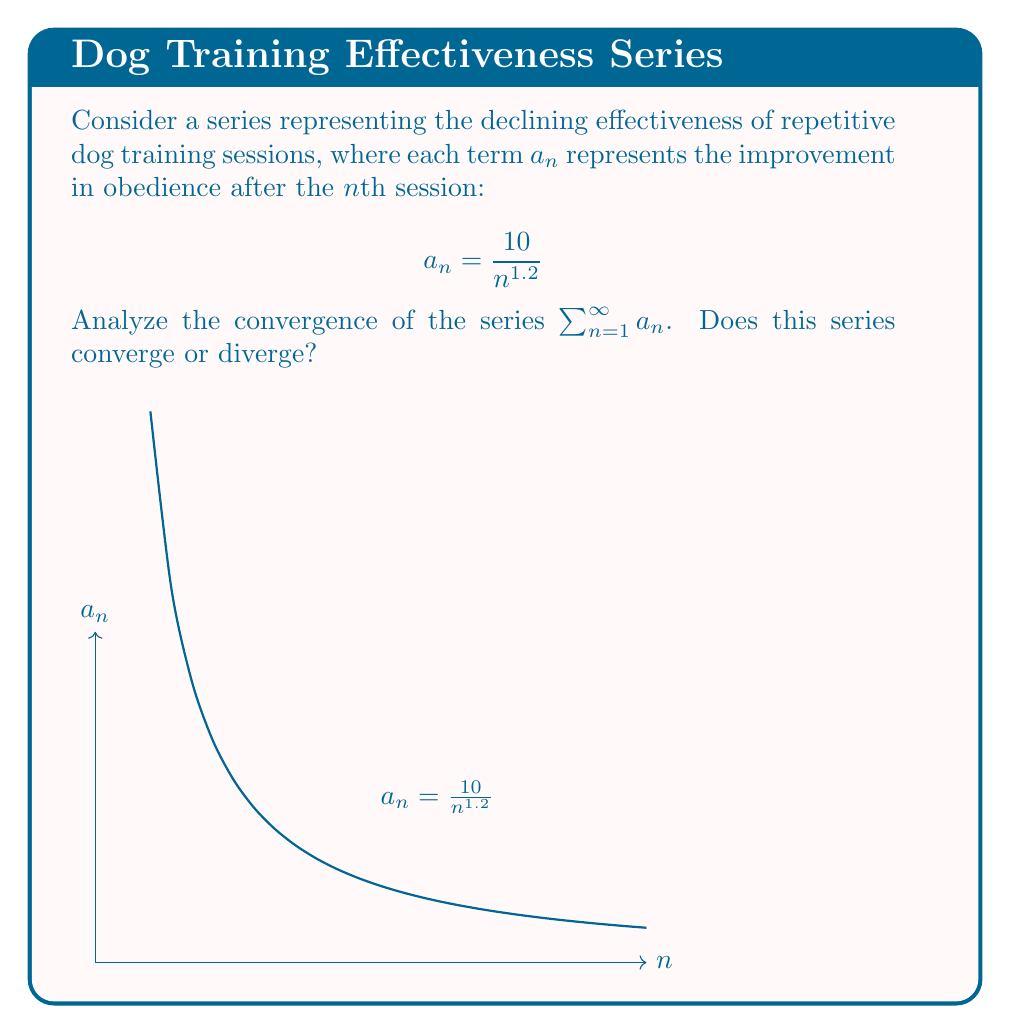What is the answer to this math problem? To analyze the convergence of this series, we can use the p-series test:

1) The general form of a p-series is $\sum_{n=1}^{\infty} \frac{1}{n^p}$

2) Our series can be rewritten as $\sum_{n=1}^{\infty} \frac{10}{n^{1.2}} = 10 \sum_{n=1}^{\infty} \frac{1}{n^{1.2}}$

3) In this case, $p = 1.2$

4) For a p-series:
   - If $p > 1$, the series converges
   - If $p \leq 1$, the series diverges

5) Since $1.2 > 1$, our series converges

6) This means that the sum of improvements from an infinite number of training sessions is finite, supporting the skepticism about the long-term effectiveness of repetitive training methods.

7) Note: The constant factor 10 doesn't affect convergence, only the rate of decay in the denominator matters.
Answer: The series converges. 